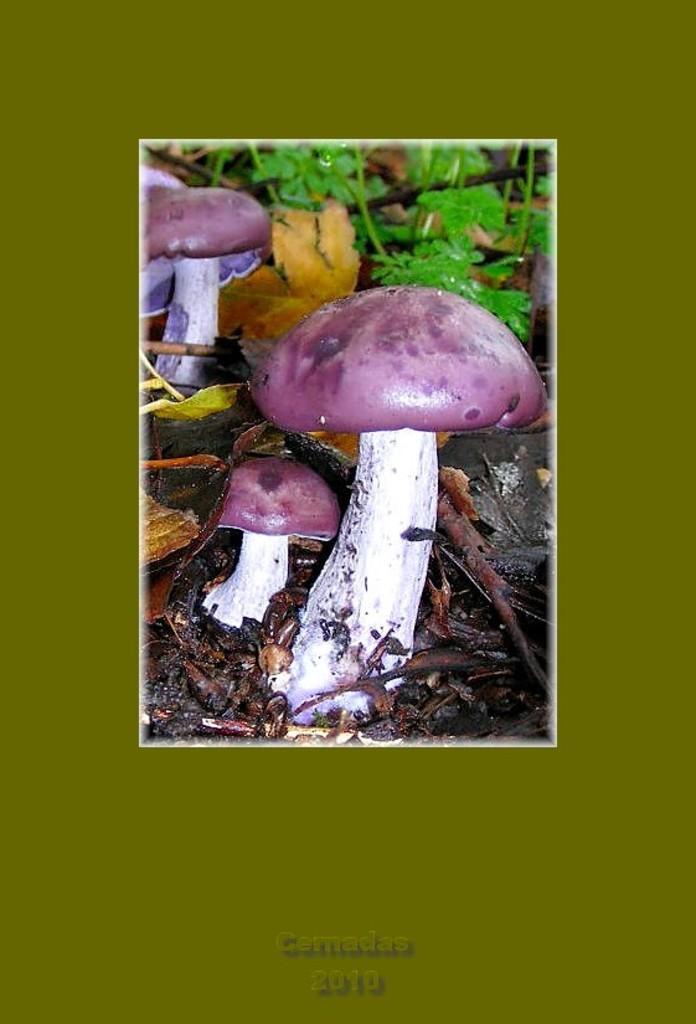In one or two sentences, can you explain what this image depicts? This image is an edited image. It has borders. In the center of the image there are mushrooms. In the background of the image there are plants. At the bottom of the image there are dried leaves. 